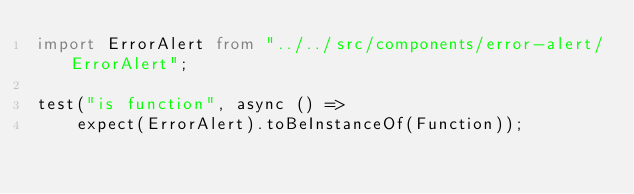<code> <loc_0><loc_0><loc_500><loc_500><_TypeScript_>import ErrorAlert from "../../src/components/error-alert/ErrorAlert";

test("is function", async () =>
    expect(ErrorAlert).toBeInstanceOf(Function));</code> 